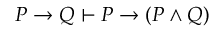<formula> <loc_0><loc_0><loc_500><loc_500>P \to Q \vdash P \to ( P \land Q )</formula> 